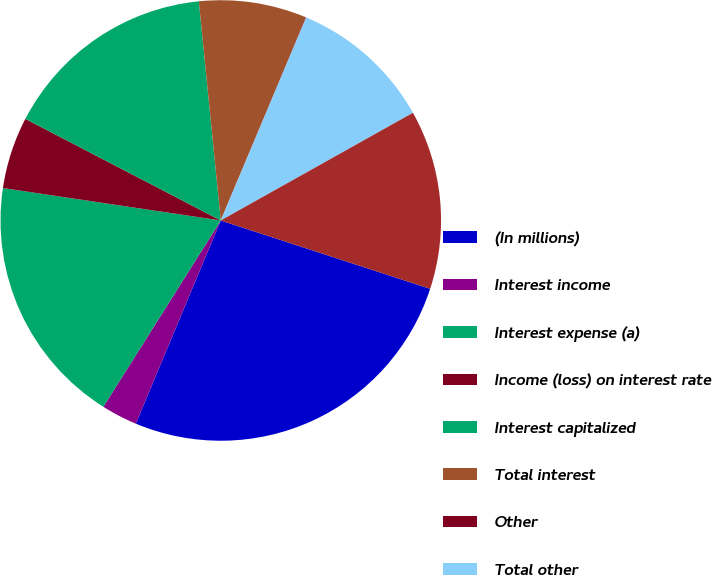Convert chart. <chart><loc_0><loc_0><loc_500><loc_500><pie_chart><fcel>(In millions)<fcel>Interest income<fcel>Interest expense (a)<fcel>Income (loss) on interest rate<fcel>Interest capitalized<fcel>Total interest<fcel>Other<fcel>Total other<fcel>Net interest and other<nl><fcel>26.28%<fcel>2.65%<fcel>18.4%<fcel>5.28%<fcel>15.78%<fcel>7.9%<fcel>0.03%<fcel>10.53%<fcel>13.15%<nl></chart> 